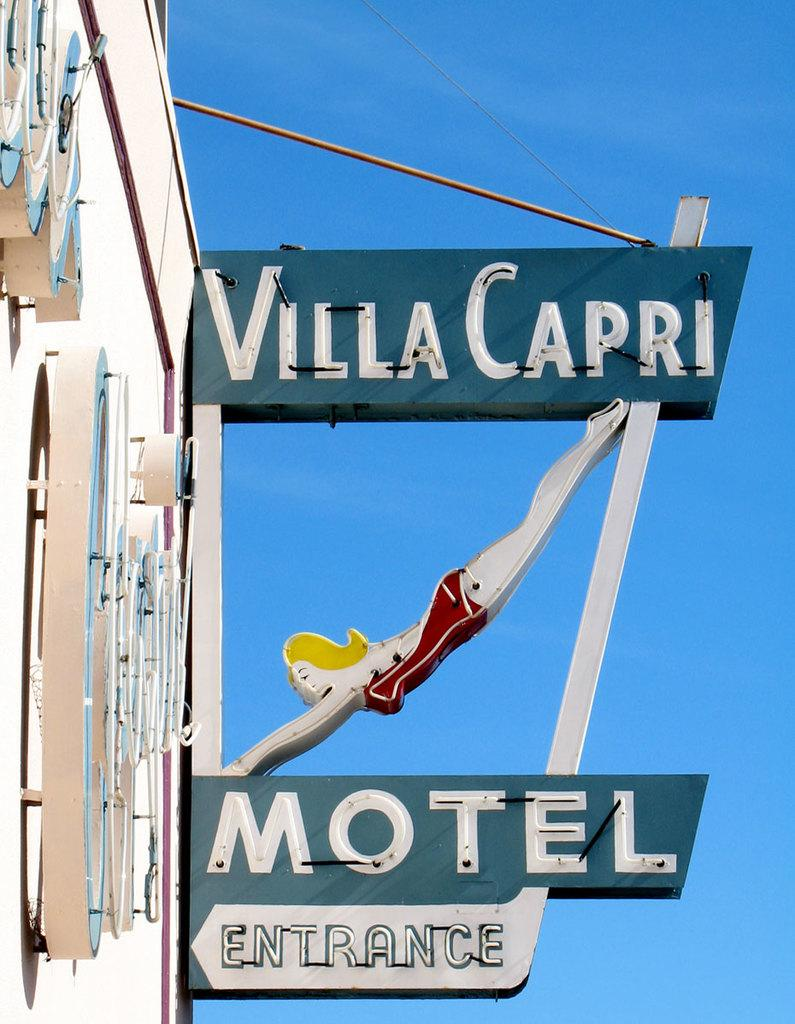<image>
Render a clear and concise summary of the photo. Sign on a building for Villa Capri Motel on a sunny day. 